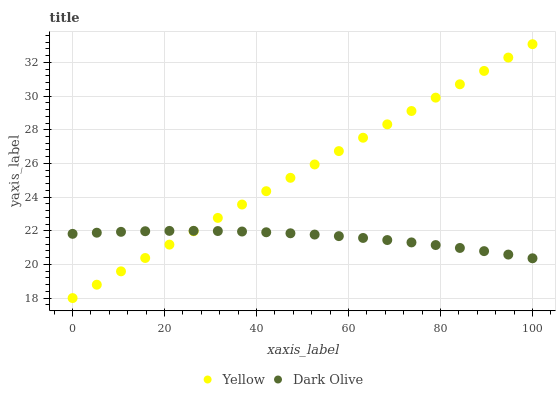Does Dark Olive have the minimum area under the curve?
Answer yes or no. Yes. Does Yellow have the maximum area under the curve?
Answer yes or no. Yes. Does Yellow have the minimum area under the curve?
Answer yes or no. No. Is Yellow the smoothest?
Answer yes or no. Yes. Is Dark Olive the roughest?
Answer yes or no. Yes. Is Yellow the roughest?
Answer yes or no. No. Does Yellow have the lowest value?
Answer yes or no. Yes. Does Yellow have the highest value?
Answer yes or no. Yes. Does Yellow intersect Dark Olive?
Answer yes or no. Yes. Is Yellow less than Dark Olive?
Answer yes or no. No. Is Yellow greater than Dark Olive?
Answer yes or no. No. 